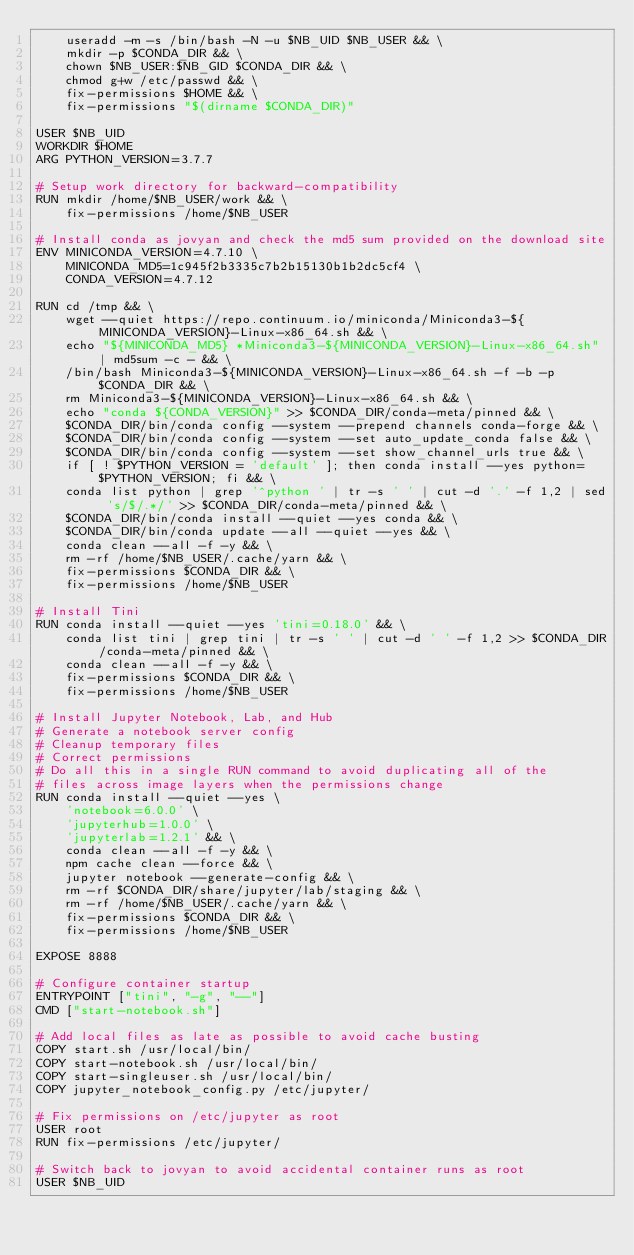<code> <loc_0><loc_0><loc_500><loc_500><_Dockerfile_>    useradd -m -s /bin/bash -N -u $NB_UID $NB_USER && \
    mkdir -p $CONDA_DIR && \
    chown $NB_USER:$NB_GID $CONDA_DIR && \
    chmod g+w /etc/passwd && \
    fix-permissions $HOME && \
    fix-permissions "$(dirname $CONDA_DIR)"

USER $NB_UID
WORKDIR $HOME
ARG PYTHON_VERSION=3.7.7

# Setup work directory for backward-compatibility
RUN mkdir /home/$NB_USER/work && \
    fix-permissions /home/$NB_USER

# Install conda as jovyan and check the md5 sum provided on the download site
ENV MINICONDA_VERSION=4.7.10 \
    MINICONDA_MD5=1c945f2b3335c7b2b15130b1b2dc5cf4 \
    CONDA_VERSION=4.7.12

RUN cd /tmp && \
    wget --quiet https://repo.continuum.io/miniconda/Miniconda3-${MINICONDA_VERSION}-Linux-x86_64.sh && \
    echo "${MINICONDA_MD5} *Miniconda3-${MINICONDA_VERSION}-Linux-x86_64.sh" | md5sum -c - && \
    /bin/bash Miniconda3-${MINICONDA_VERSION}-Linux-x86_64.sh -f -b -p $CONDA_DIR && \
    rm Miniconda3-${MINICONDA_VERSION}-Linux-x86_64.sh && \
    echo "conda ${CONDA_VERSION}" >> $CONDA_DIR/conda-meta/pinned && \
    $CONDA_DIR/bin/conda config --system --prepend channels conda-forge && \
    $CONDA_DIR/bin/conda config --system --set auto_update_conda false && \
    $CONDA_DIR/bin/conda config --system --set show_channel_urls true && \
    if [ ! $PYTHON_VERSION = 'default' ]; then conda install --yes python=$PYTHON_VERSION; fi && \
    conda list python | grep '^python ' | tr -s ' ' | cut -d '.' -f 1,2 | sed 's/$/.*/' >> $CONDA_DIR/conda-meta/pinned && \
    $CONDA_DIR/bin/conda install --quiet --yes conda && \
    $CONDA_DIR/bin/conda update --all --quiet --yes && \
    conda clean --all -f -y && \
    rm -rf /home/$NB_USER/.cache/yarn && \
    fix-permissions $CONDA_DIR && \
    fix-permissions /home/$NB_USER

# Install Tini
RUN conda install --quiet --yes 'tini=0.18.0' && \
    conda list tini | grep tini | tr -s ' ' | cut -d ' ' -f 1,2 >> $CONDA_DIR/conda-meta/pinned && \
    conda clean --all -f -y && \
    fix-permissions $CONDA_DIR && \
    fix-permissions /home/$NB_USER

# Install Jupyter Notebook, Lab, and Hub
# Generate a notebook server config
# Cleanup temporary files
# Correct permissions
# Do all this in a single RUN command to avoid duplicating all of the
# files across image layers when the permissions change
RUN conda install --quiet --yes \
    'notebook=6.0.0' \
    'jupyterhub=1.0.0' \
    'jupyterlab=1.2.1' && \
    conda clean --all -f -y && \
    npm cache clean --force && \
    jupyter notebook --generate-config && \
    rm -rf $CONDA_DIR/share/jupyter/lab/staging && \
    rm -rf /home/$NB_USER/.cache/yarn && \
    fix-permissions $CONDA_DIR && \
    fix-permissions /home/$NB_USER

EXPOSE 8888

# Configure container startup
ENTRYPOINT ["tini", "-g", "--"]
CMD ["start-notebook.sh"]

# Add local files as late as possible to avoid cache busting
COPY start.sh /usr/local/bin/
COPY start-notebook.sh /usr/local/bin/
COPY start-singleuser.sh /usr/local/bin/
COPY jupyter_notebook_config.py /etc/jupyter/

# Fix permissions on /etc/jupyter as root
USER root
RUN fix-permissions /etc/jupyter/

# Switch back to jovyan to avoid accidental container runs as root
USER $NB_UID
</code> 